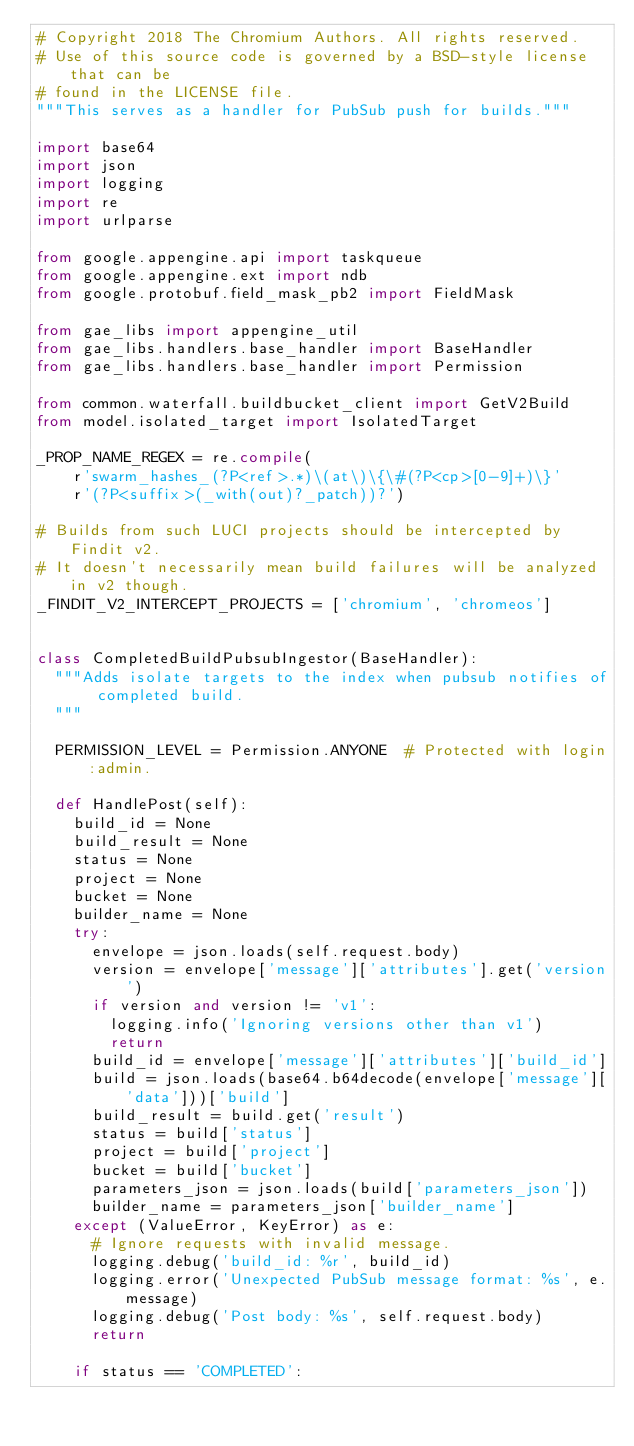Convert code to text. <code><loc_0><loc_0><loc_500><loc_500><_Python_># Copyright 2018 The Chromium Authors. All rights reserved.
# Use of this source code is governed by a BSD-style license that can be
# found in the LICENSE file.
"""This serves as a handler for PubSub push for builds."""

import base64
import json
import logging
import re
import urlparse

from google.appengine.api import taskqueue
from google.appengine.ext import ndb
from google.protobuf.field_mask_pb2 import FieldMask

from gae_libs import appengine_util
from gae_libs.handlers.base_handler import BaseHandler
from gae_libs.handlers.base_handler import Permission

from common.waterfall.buildbucket_client import GetV2Build
from model.isolated_target import IsolatedTarget

_PROP_NAME_REGEX = re.compile(
    r'swarm_hashes_(?P<ref>.*)\(at\)\{\#(?P<cp>[0-9]+)\}'
    r'(?P<suffix>(_with(out)?_patch))?')

# Builds from such LUCI projects should be intercepted by Findit v2.
# It doesn't necessarily mean build failures will be analyzed in v2 though.
_FINDIT_V2_INTERCEPT_PROJECTS = ['chromium', 'chromeos']


class CompletedBuildPubsubIngestor(BaseHandler):
  """Adds isolate targets to the index when pubsub notifies of completed build.
  """

  PERMISSION_LEVEL = Permission.ANYONE  # Protected with login:admin.

  def HandlePost(self):
    build_id = None
    build_result = None
    status = None
    project = None
    bucket = None
    builder_name = None
    try:
      envelope = json.loads(self.request.body)
      version = envelope['message']['attributes'].get('version')
      if version and version != 'v1':
        logging.info('Ignoring versions other than v1')
        return
      build_id = envelope['message']['attributes']['build_id']
      build = json.loads(base64.b64decode(envelope['message']['data']))['build']
      build_result = build.get('result')
      status = build['status']
      project = build['project']
      bucket = build['bucket']
      parameters_json = json.loads(build['parameters_json'])
      builder_name = parameters_json['builder_name']
    except (ValueError, KeyError) as e:
      # Ignore requests with invalid message.
      logging.debug('build_id: %r', build_id)
      logging.error('Unexpected PubSub message format: %s', e.message)
      logging.debug('Post body: %s', self.request.body)
      return

    if status == 'COMPLETED':</code> 